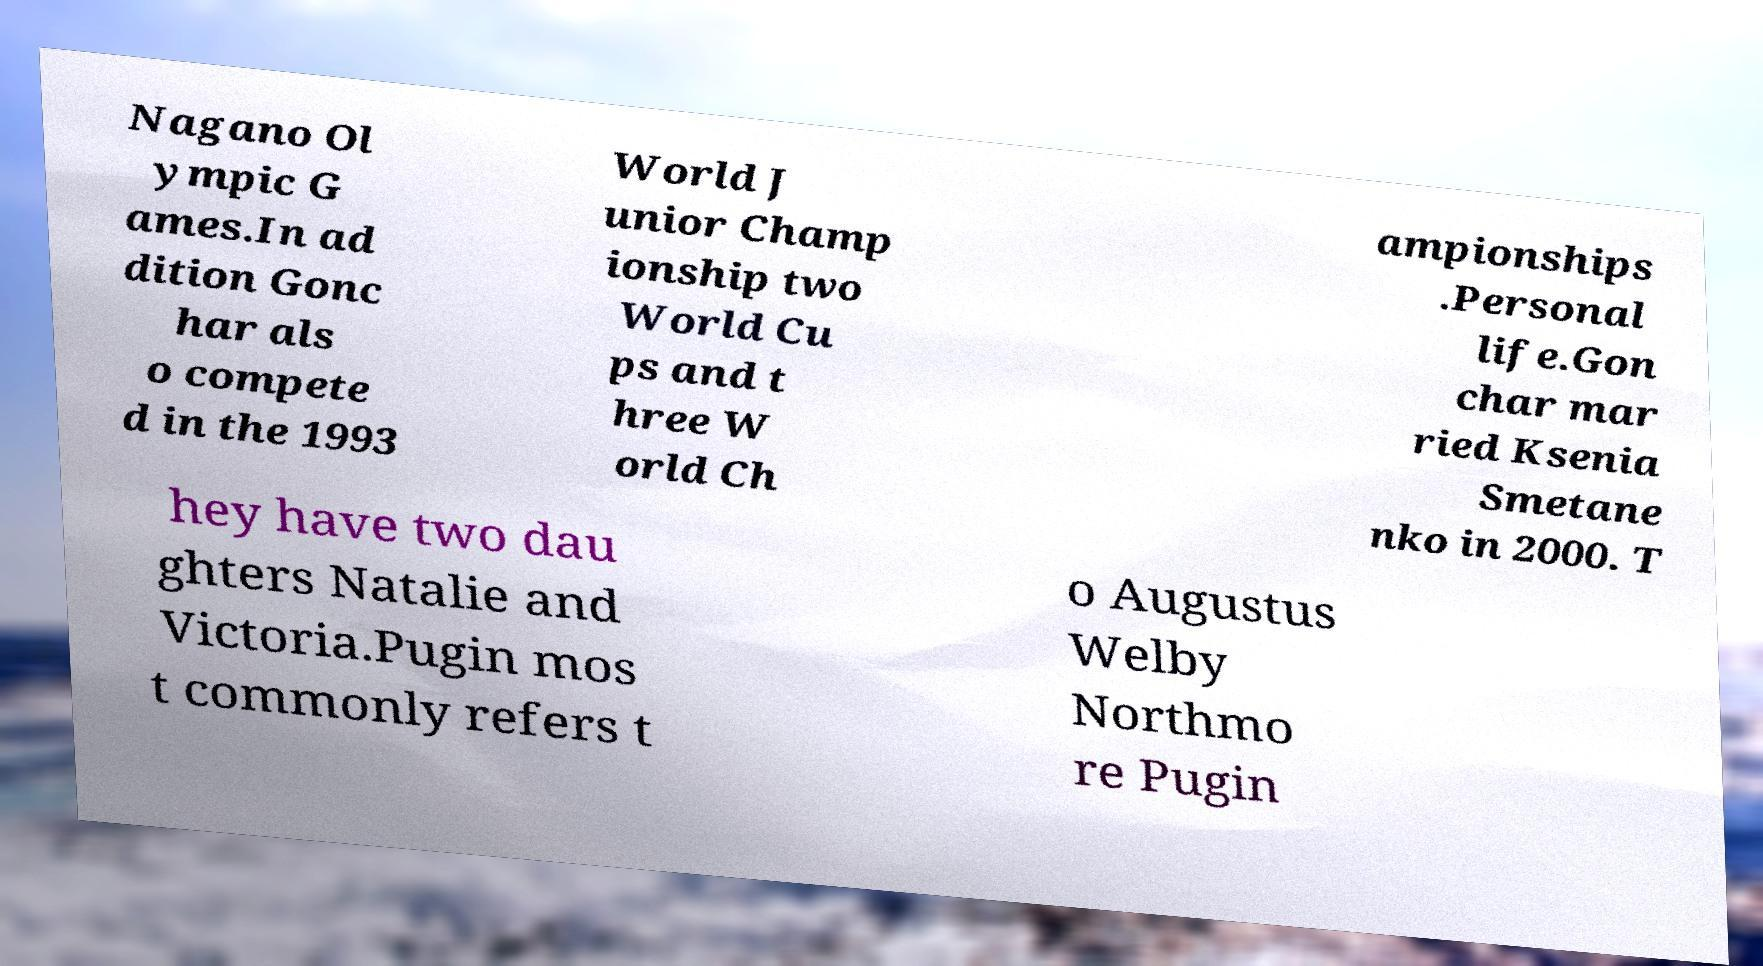Please read and relay the text visible in this image. What does it say? Nagano Ol ympic G ames.In ad dition Gonc har als o compete d in the 1993 World J unior Champ ionship two World Cu ps and t hree W orld Ch ampionships .Personal life.Gon char mar ried Ksenia Smetane nko in 2000. T hey have two dau ghters Natalie and Victoria.Pugin mos t commonly refers t o Augustus Welby Northmo re Pugin 